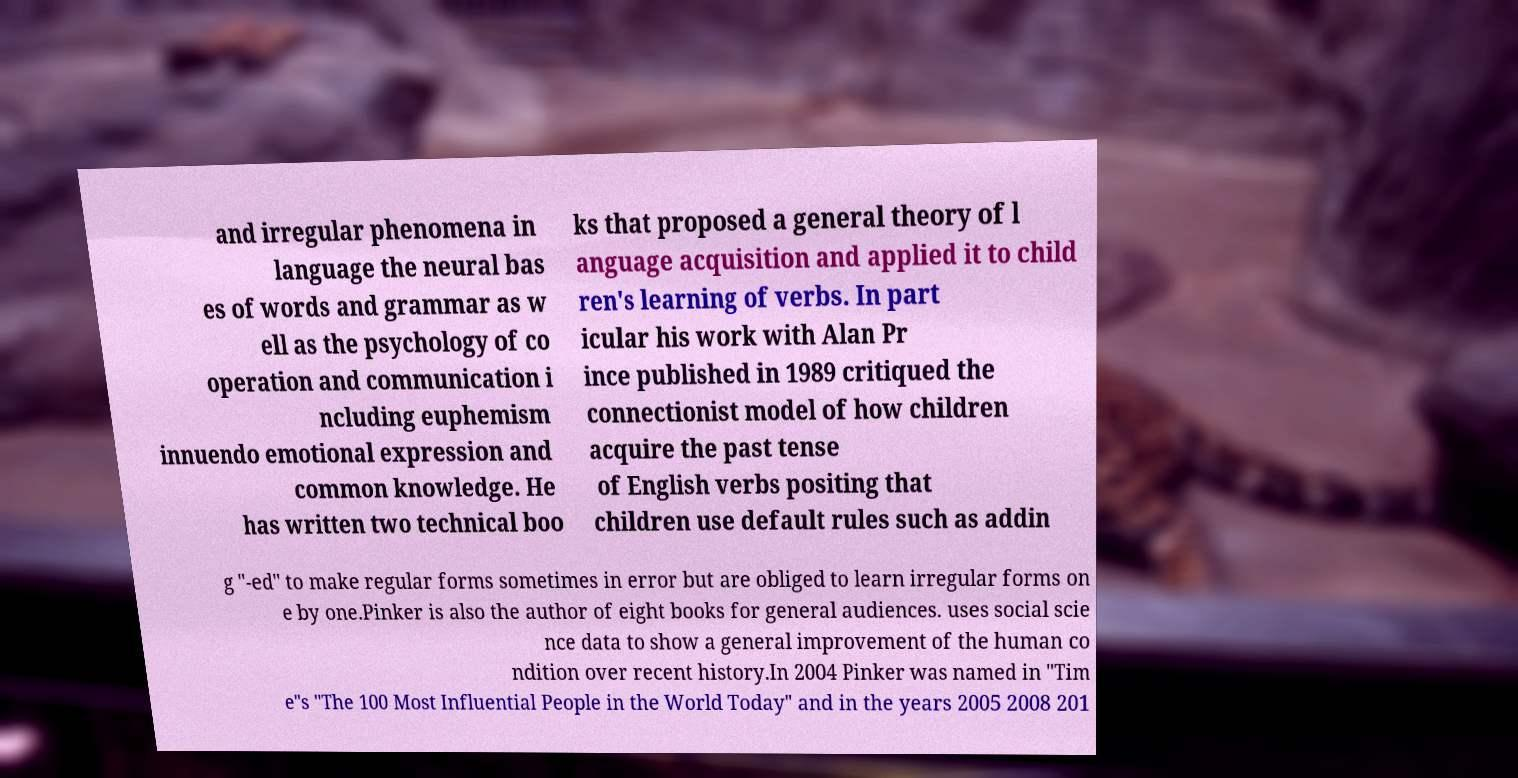For documentation purposes, I need the text within this image transcribed. Could you provide that? and irregular phenomena in language the neural bas es of words and grammar as w ell as the psychology of co operation and communication i ncluding euphemism innuendo emotional expression and common knowledge. He has written two technical boo ks that proposed a general theory of l anguage acquisition and applied it to child ren's learning of verbs. In part icular his work with Alan Pr ince published in 1989 critiqued the connectionist model of how children acquire the past tense of English verbs positing that children use default rules such as addin g "-ed" to make regular forms sometimes in error but are obliged to learn irregular forms on e by one.Pinker is also the author of eight books for general audiences. uses social scie nce data to show a general improvement of the human co ndition over recent history.In 2004 Pinker was named in "Tim e"s "The 100 Most Influential People in the World Today" and in the years 2005 2008 201 